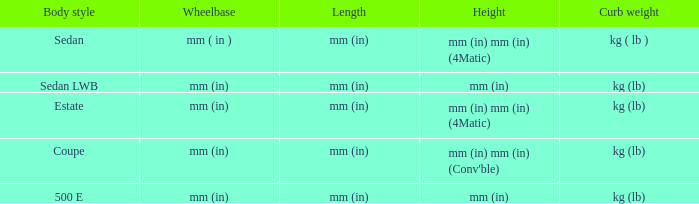What's the length of the model with Sedan body style? Mm (in). 